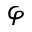Convert formula to latex. <formula><loc_0><loc_0><loc_500><loc_500>\varphi</formula> 